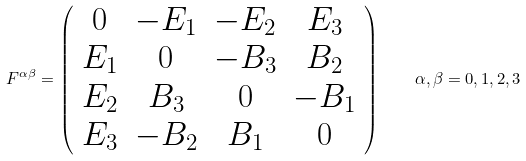<formula> <loc_0><loc_0><loc_500><loc_500>F ^ { \alpha \beta } = \left ( \begin{array} { c c c c } 0 & - E _ { 1 } & - E _ { 2 } & E _ { 3 } \\ E _ { 1 } & 0 & - B _ { 3 } & B _ { 2 } \\ E _ { 2 } & B _ { 3 } & 0 & - B _ { 1 } \\ E _ { 3 } & - B _ { 2 } & B _ { 1 } & 0 \end{array} \right ) \quad \alpha , \beta = 0 , 1 , 2 , 3</formula> 